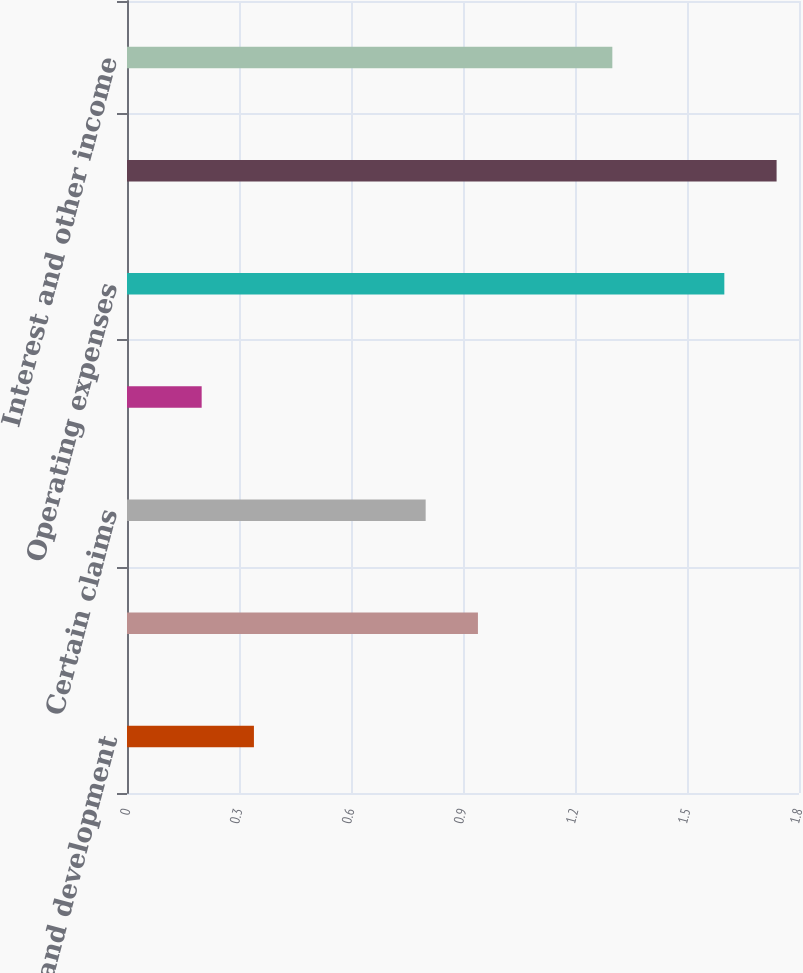<chart> <loc_0><loc_0><loc_500><loc_500><bar_chart><fcel>Research and development<fcel>Selling general and<fcel>Certain claims<fcel>Acquisition integration<fcel>Operating expenses<fcel>Operating profit<fcel>Interest and other income<nl><fcel>0.34<fcel>0.94<fcel>0.8<fcel>0.2<fcel>1.6<fcel>1.74<fcel>1.3<nl></chart> 